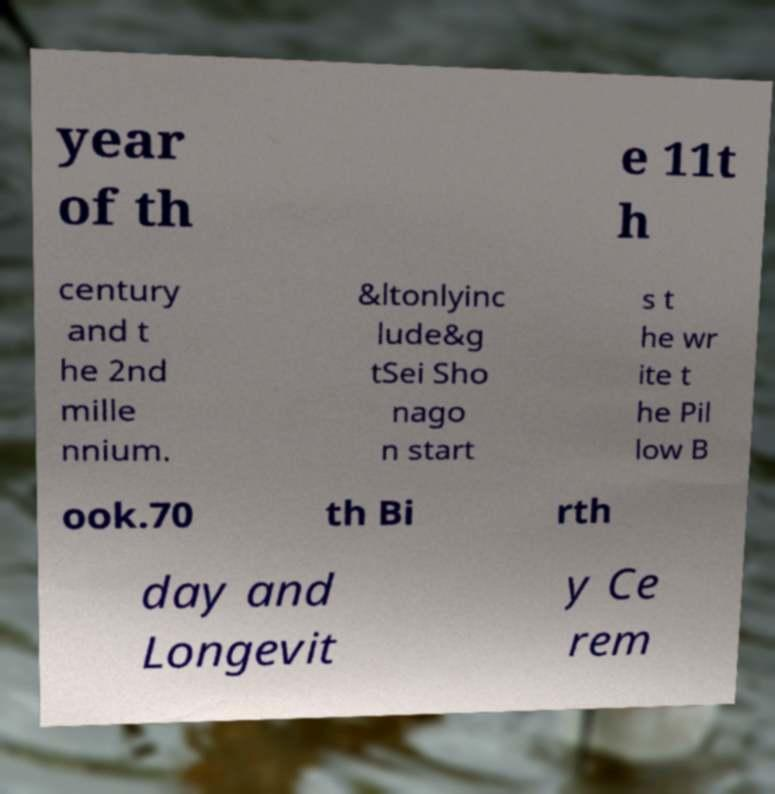I need the written content from this picture converted into text. Can you do that? year of th e 11t h century and t he 2nd mille nnium. &ltonlyinc lude&g tSei Sho nago n start s t he wr ite t he Pil low B ook.70 th Bi rth day and Longevit y Ce rem 